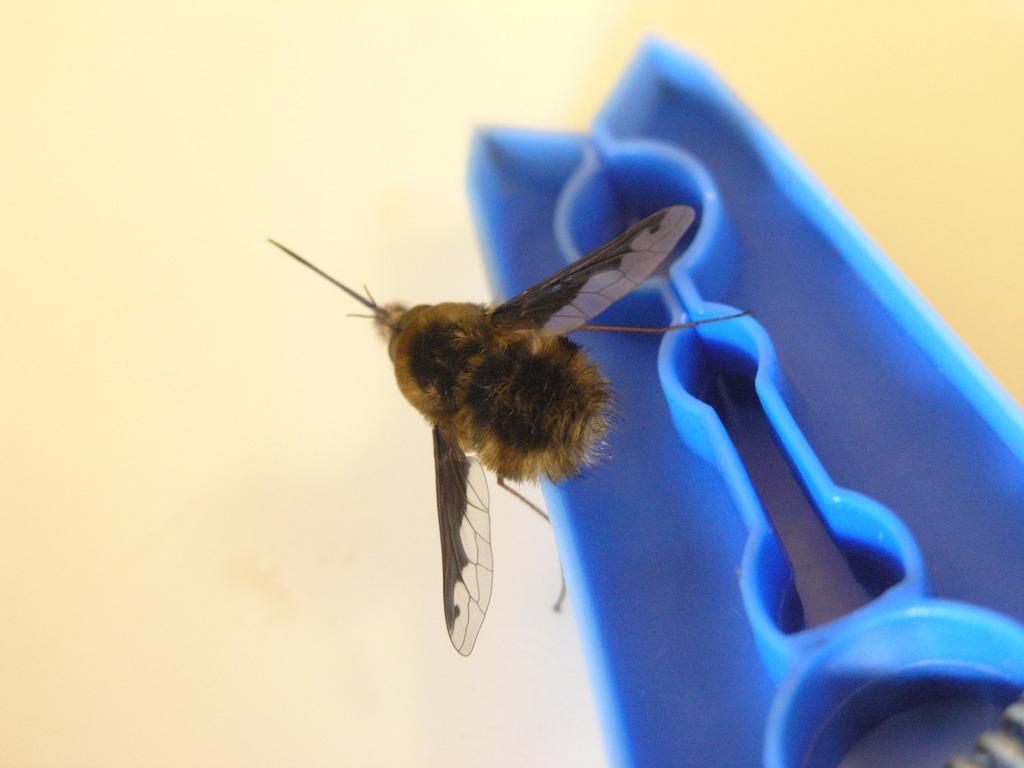Please provide a concise description of this image. In this image I can see an insect which is brown and black in color and a blue colored object. I can see the cream colored background. 